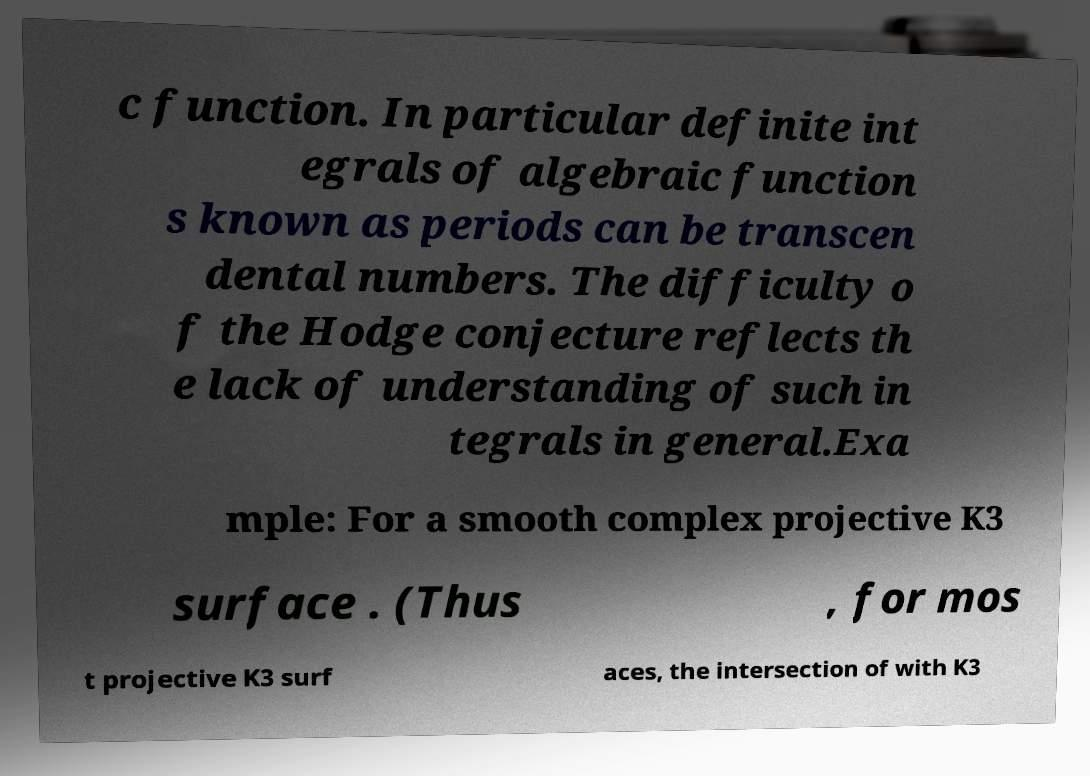I need the written content from this picture converted into text. Can you do that? c function. In particular definite int egrals of algebraic function s known as periods can be transcen dental numbers. The difficulty o f the Hodge conjecture reflects th e lack of understanding of such in tegrals in general.Exa mple: For a smooth complex projective K3 surface . (Thus , for mos t projective K3 surf aces, the intersection of with K3 